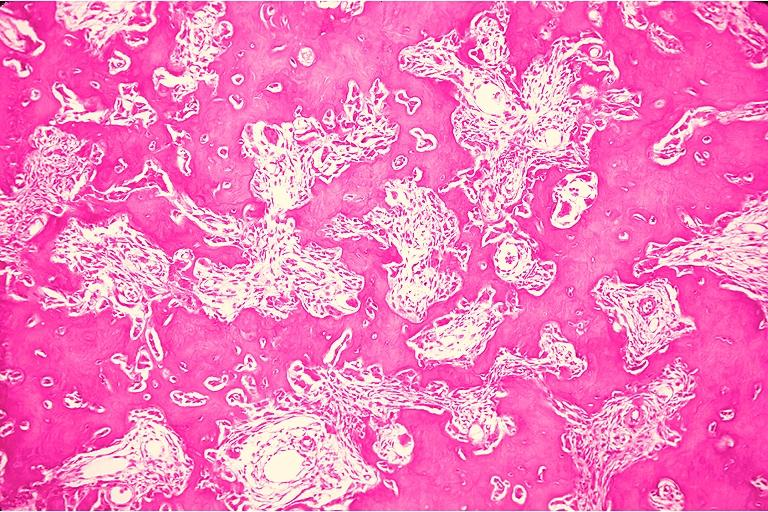does median lobe hyperplasia with marked cystitis and bladder hypertrophy ureter show osteoblastoma?
Answer the question using a single word or phrase. No 